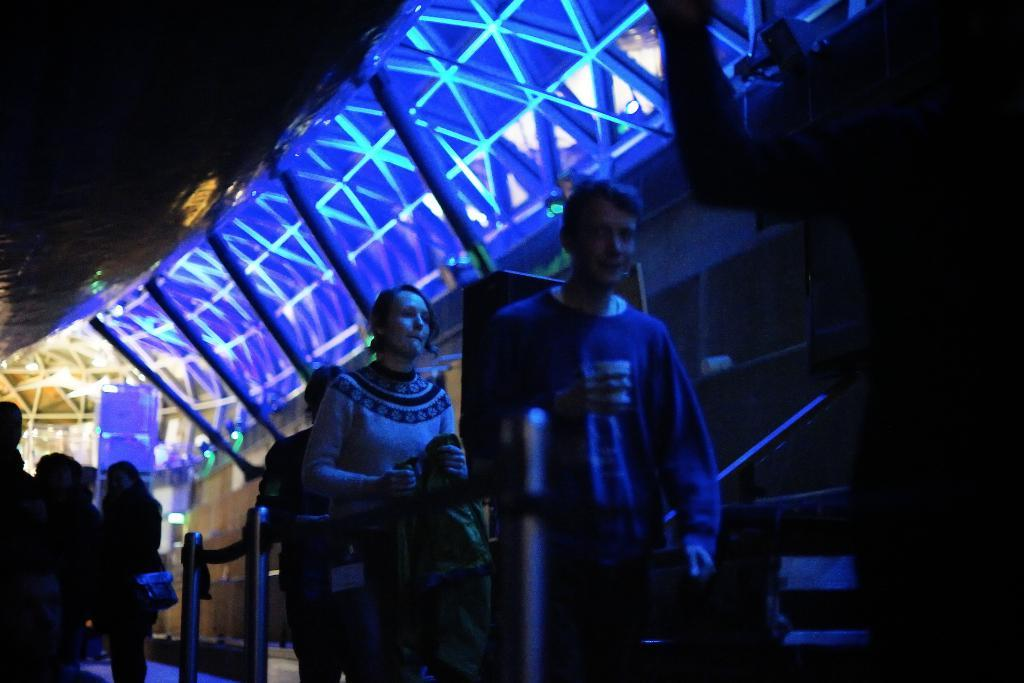What are the people in the image doing? The people in the image are walking. What is the lighting condition in the image? The people are walking in the dark. Where are the people walking in the image? The people are walking under a shed. What is the color of the focus light in the image? There is a blue color focus light in the image. What type of question is being asked by the person in the image? There is no person asking a question in the image; the people are walking. What is the cook preparing in the image? There is no cook or preparation of food in the image; it features people walking under a shed. 